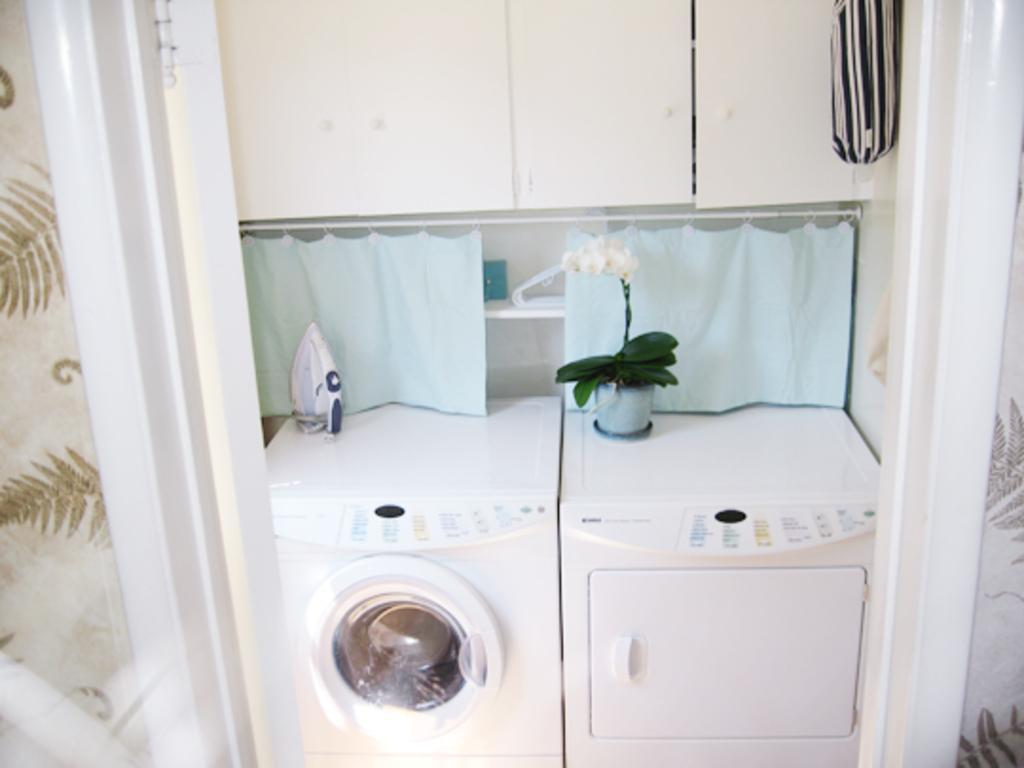Can you describe this image briefly? In this picture we can see washing machines, here we can see an iron box, clothes and some objects and we can see a wall in the background. 